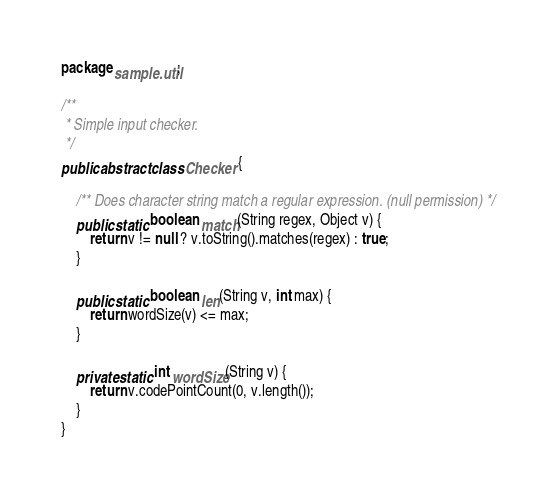<code> <loc_0><loc_0><loc_500><loc_500><_Java_>package sample.util;

/**
 * Simple input checker.
 */
public abstract class Checker {

    /** Does character string match a regular expression. (null permission) */
    public static boolean match(String regex, Object v) {
        return v != null ? v.toString().matches(regex) : true;
    }

    public static boolean len(String v, int max) {
        return wordSize(v) <= max;
    }

    private static int wordSize(String v) {
        return v.codePointCount(0, v.length());
    }
}
</code> 